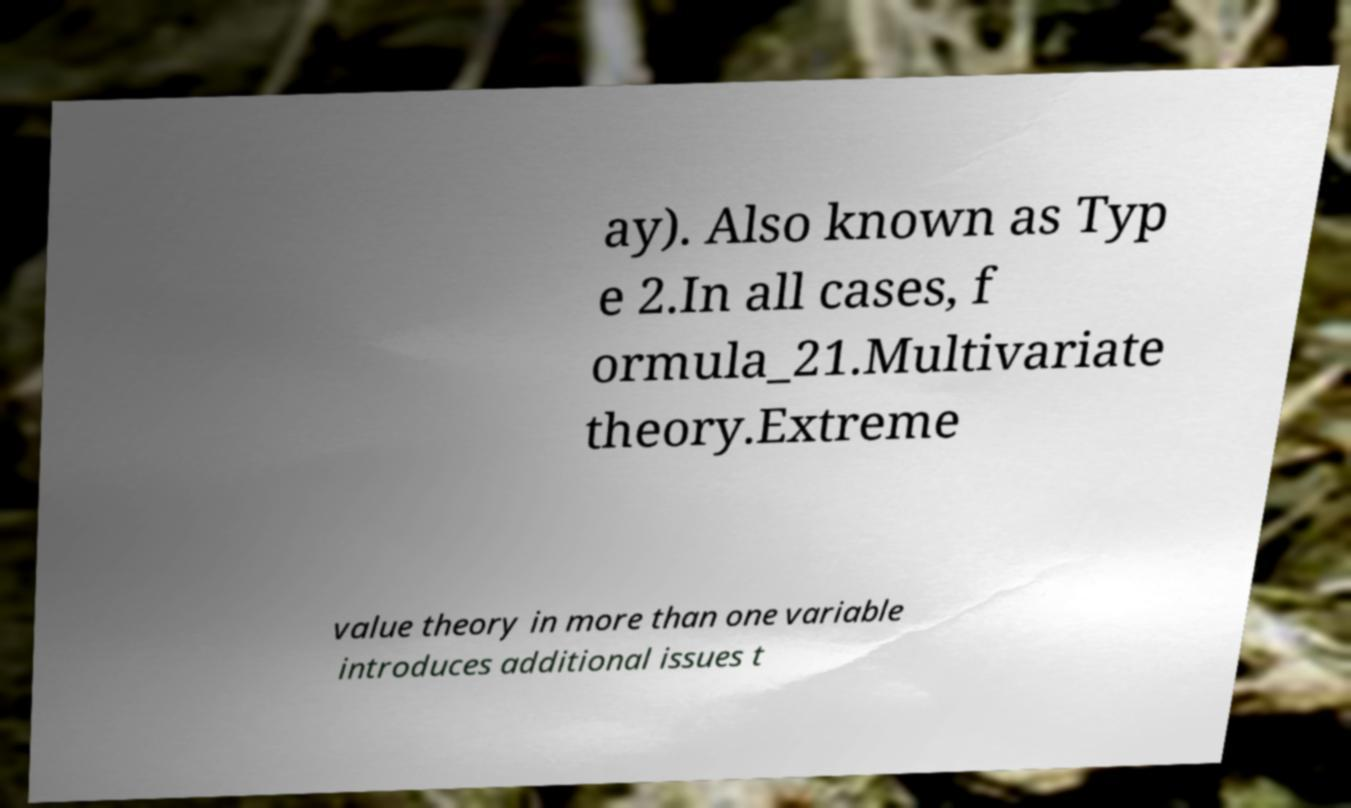Please read and relay the text visible in this image. What does it say? ay). Also known as Typ e 2.In all cases, f ormula_21.Multivariate theory.Extreme value theory in more than one variable introduces additional issues t 